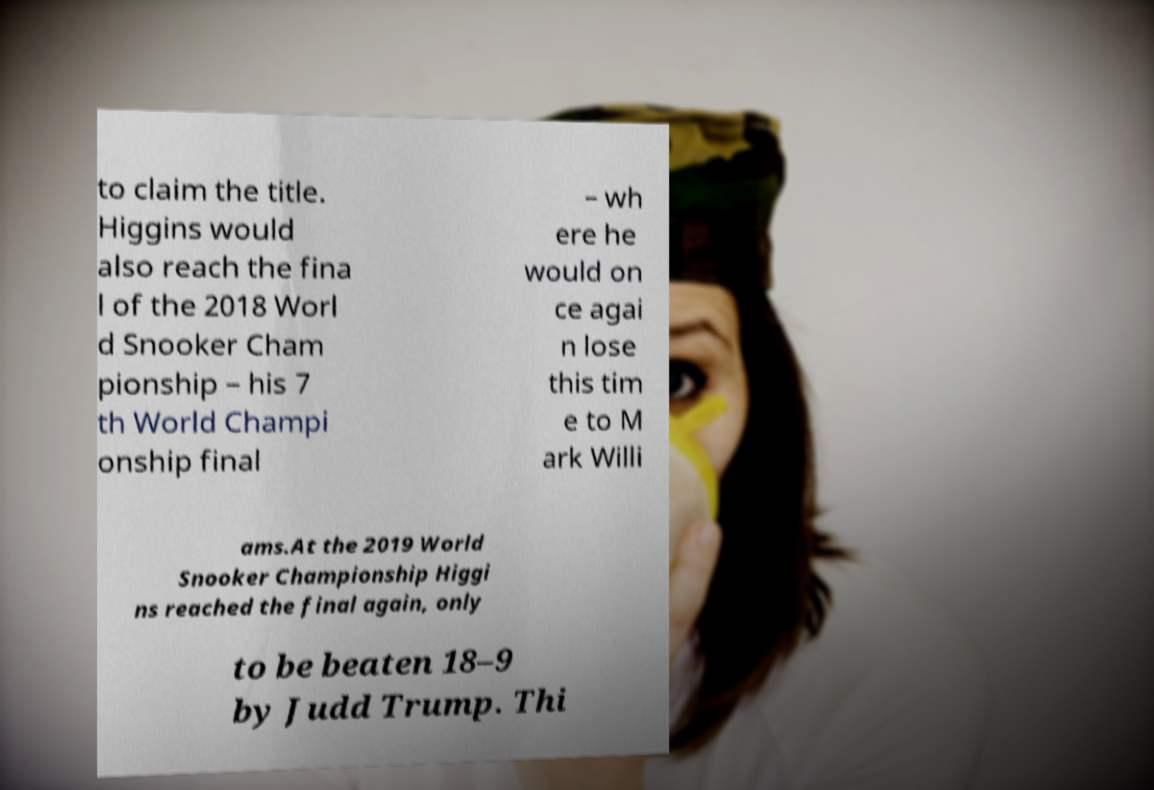Can you read and provide the text displayed in the image?This photo seems to have some interesting text. Can you extract and type it out for me? to claim the title. Higgins would also reach the fina l of the 2018 Worl d Snooker Cham pionship – his 7 th World Champi onship final – wh ere he would on ce agai n lose this tim e to M ark Willi ams.At the 2019 World Snooker Championship Higgi ns reached the final again, only to be beaten 18–9 by Judd Trump. Thi 